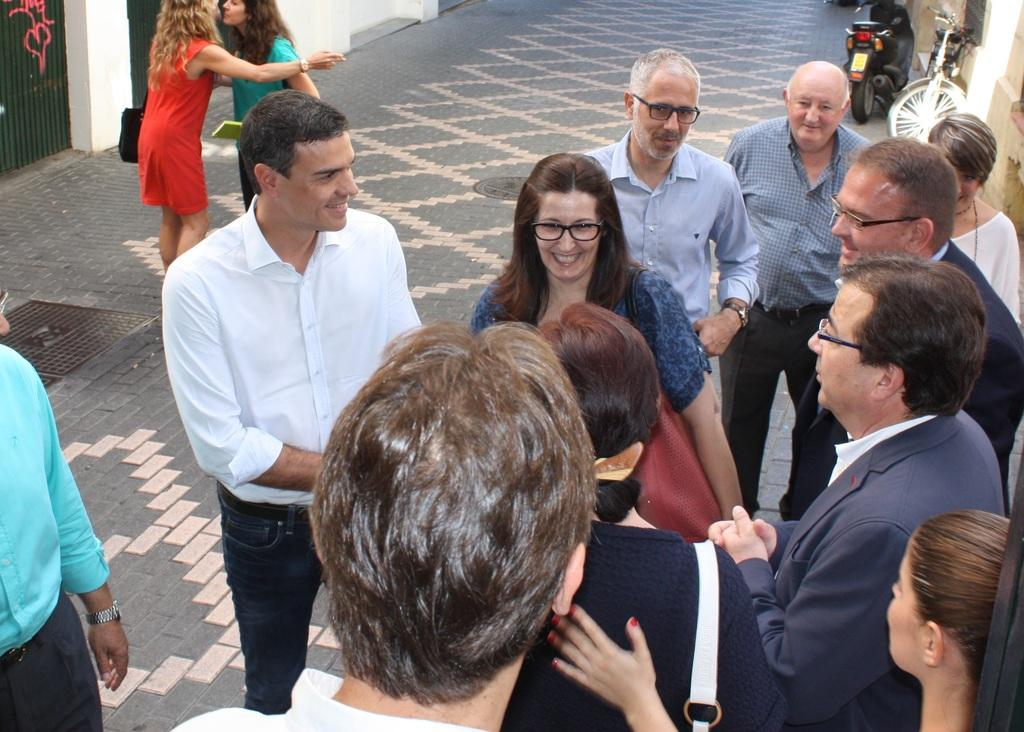What is happening in the image? There is a group of people standing in the image. What else can be seen in the image besides the people? There are vehicles and walls in the image. How many bears are visible in the image? There are no bears present in the image. What type of zipper can be seen on the clothing of the people in the image? There is no information about the clothing of the people or the presence of a zipper in the image. 